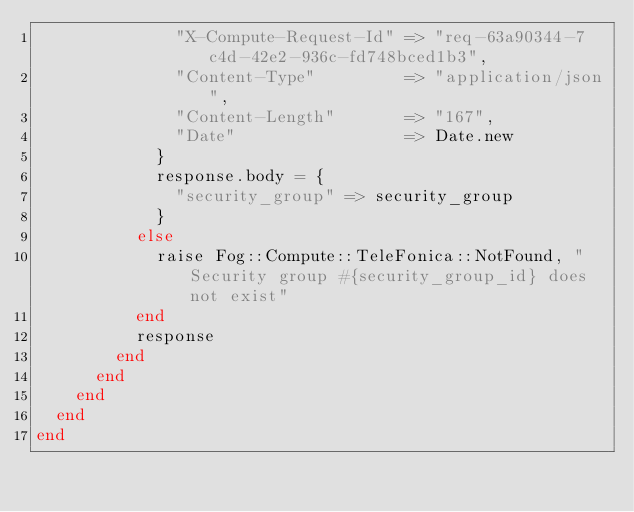<code> <loc_0><loc_0><loc_500><loc_500><_Ruby_>              "X-Compute-Request-Id" => "req-63a90344-7c4d-42e2-936c-fd748bced1b3",
              "Content-Type"         => "application/json",
              "Content-Length"       => "167",
              "Date"                 => Date.new
            }
            response.body = {
              "security_group" => security_group
            }
          else
            raise Fog::Compute::TeleFonica::NotFound, "Security group #{security_group_id} does not exist"
          end
          response
        end
      end
    end
  end
end
</code> 